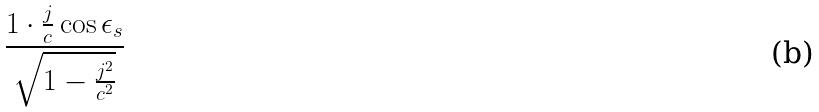Convert formula to latex. <formula><loc_0><loc_0><loc_500><loc_500>\frac { 1 \cdot \frac { j } { c } \cos \epsilon _ { s } } { \sqrt { 1 - \frac { j ^ { 2 } } { c ^ { 2 } } } }</formula> 